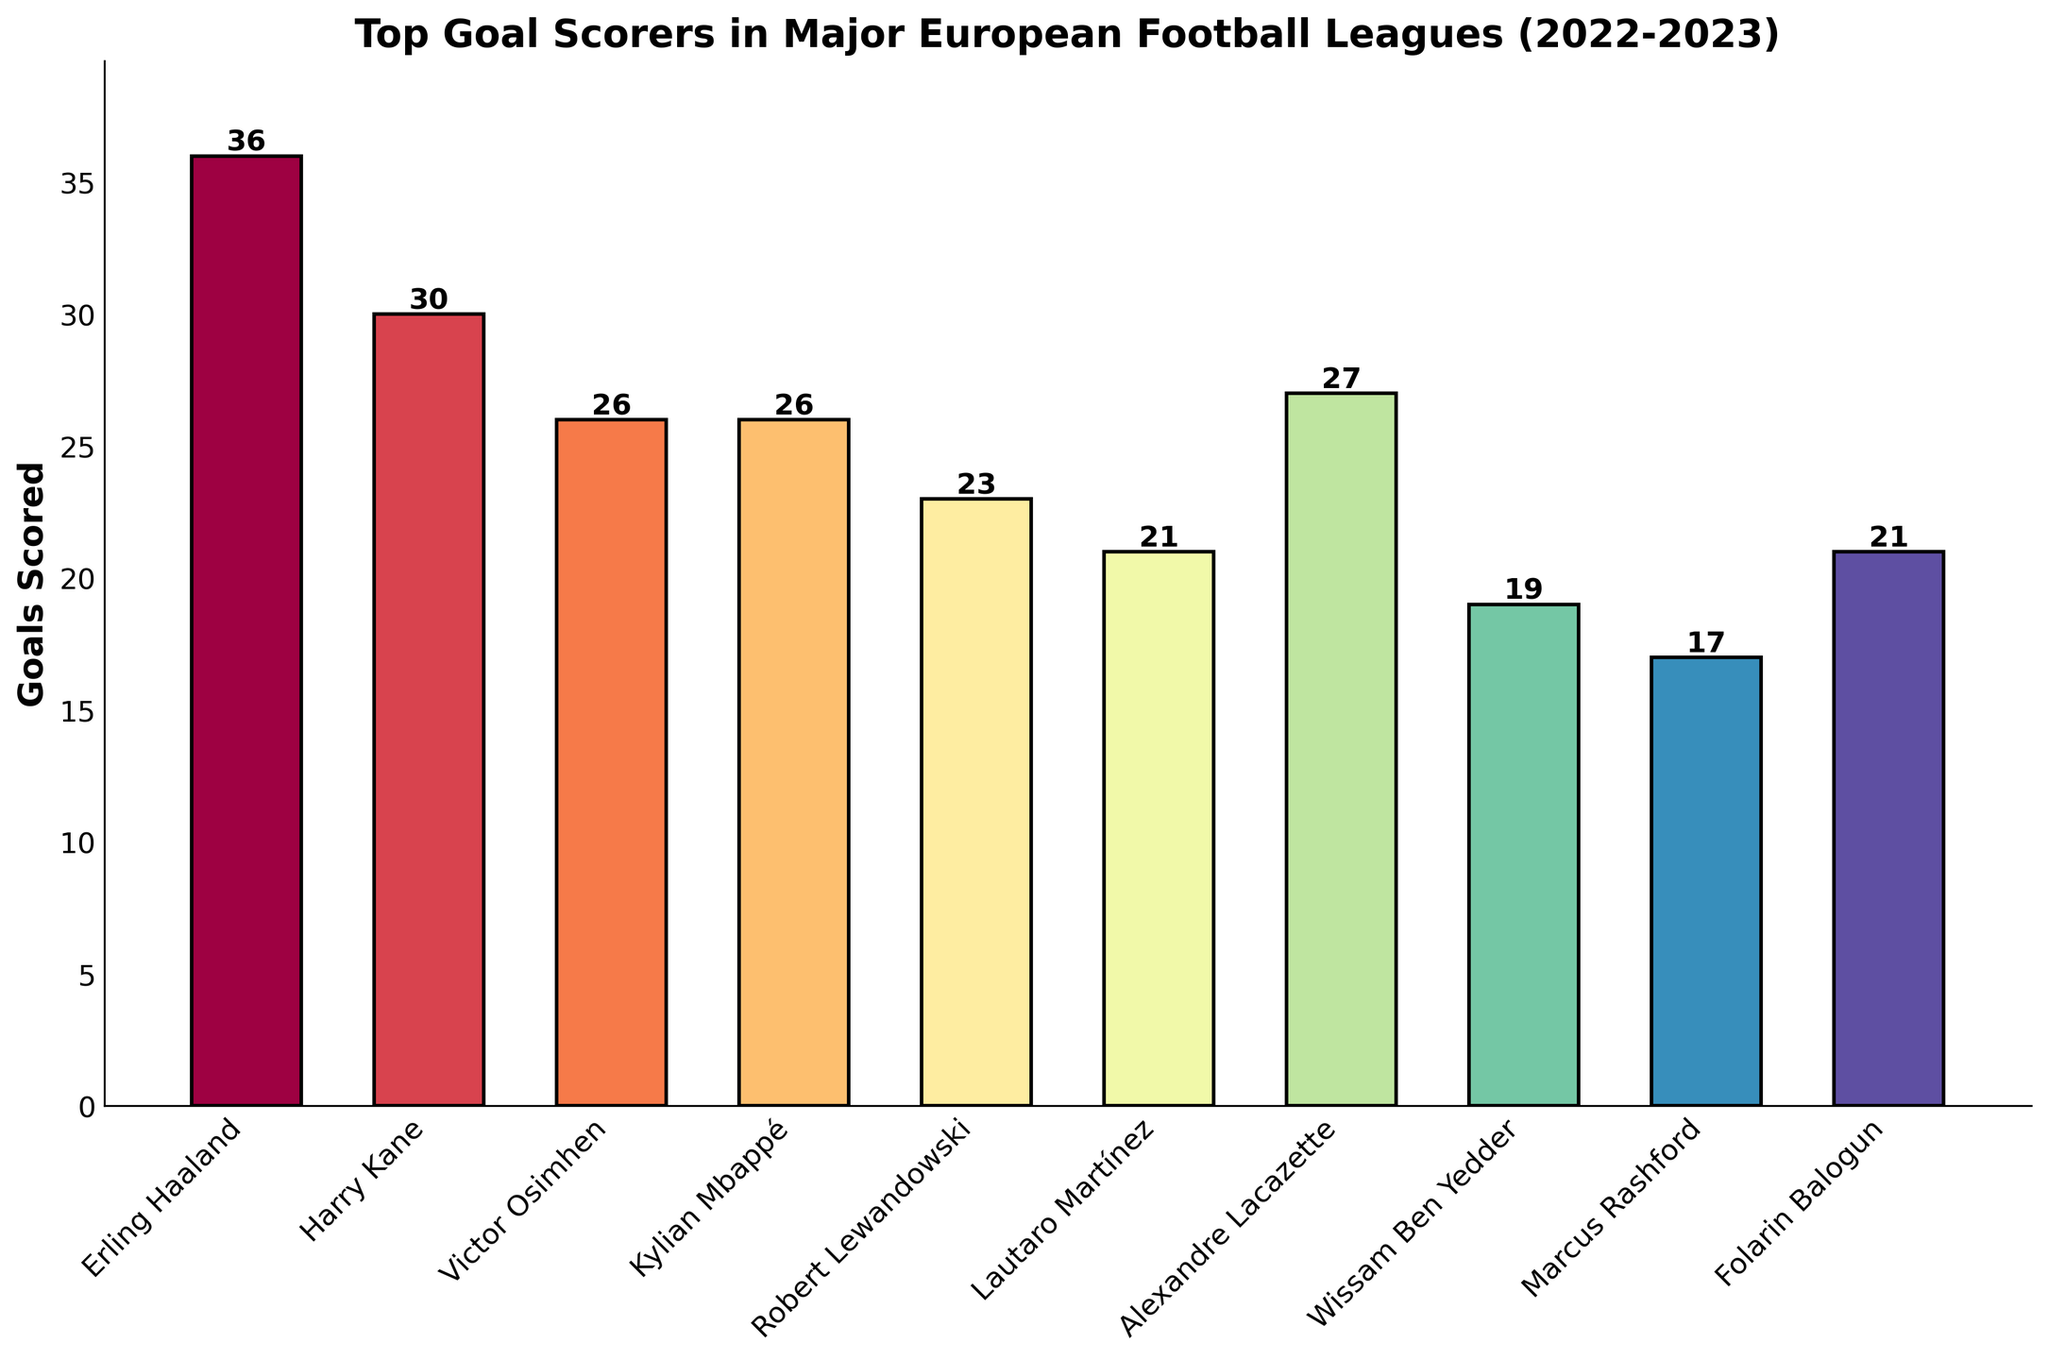Who scored the highest number of goals? Erling Haaland's bar is the tallest in the plot, indicating 36 goals, the highest among all players listed.
Answer: Erling Haaland How many goals did the top three goal scorers score collectively? Erling Haaland scored 36, Harry Kane scored 30, and Alexandre Lacazette scored 27. Adding these up: 36 + 30 + 27 = 93.
Answer: 93 What is the difference in goals scored between Kylian Mbappé and Wissam Ben Yedder? Kylian Mbappé scored 26 goals, while Wissam Ben Yedder scored 19. The difference is 26 - 19 = 7.
Answer: 7 Which player scored fewer goals: Robert Lewandowski or Lautaro Martínez? Comparing the heights of their bars, Robert Lewandowski scored 23 goals and Lautaro Martínez scored 21 goals. Lautaro Martínez scored fewer goals.
Answer: Lautaro Martínez What is the average number of goals scored among all players? Sum the goals of all players (36+30+26+26+23+21+27+19+17+21) which equals 246. Divide by the number of players (10). 246 / 10 = 24.6.
Answer: 24.6 Which player scored exactly 30 goals? The bar labeled with 30 goals belongs to Harry Kane, indicating he scored exactly 30 goals.
Answer: Harry Kane How many more goals did Erling Haaland score than Marcus Rashford? Erling Haaland scored 36 and Marcus Rashford scored 17. The difference is 36 - 17 = 19.
Answer: 19 What is the total number of goals scored by players who scored more than 20 goals? Players who scored more than 20 goals are: Erling Haaland (36), Harry Kane (30), Victor Osimhen (26), Kylian Mbappé (26), Robert Lewandowski (23), Alexandre Lacazette (27), Lautaro Martínez (21), and Folarin Balogun (21). Sum: 36 + 30 + 26 + 26 + 23 + 27 + 21 + 21 = 210.
Answer: 210 Which players scored the same number of goals? Victor Osimhen and Kylian Mbappé each scored 26 goals, and Lautaro Martínez and Folarin Balogun each scored 21 goals.
Answer: Victor Osimhen and Kylian Mbappé; Lautaro Martínez and Folarin Balogun 